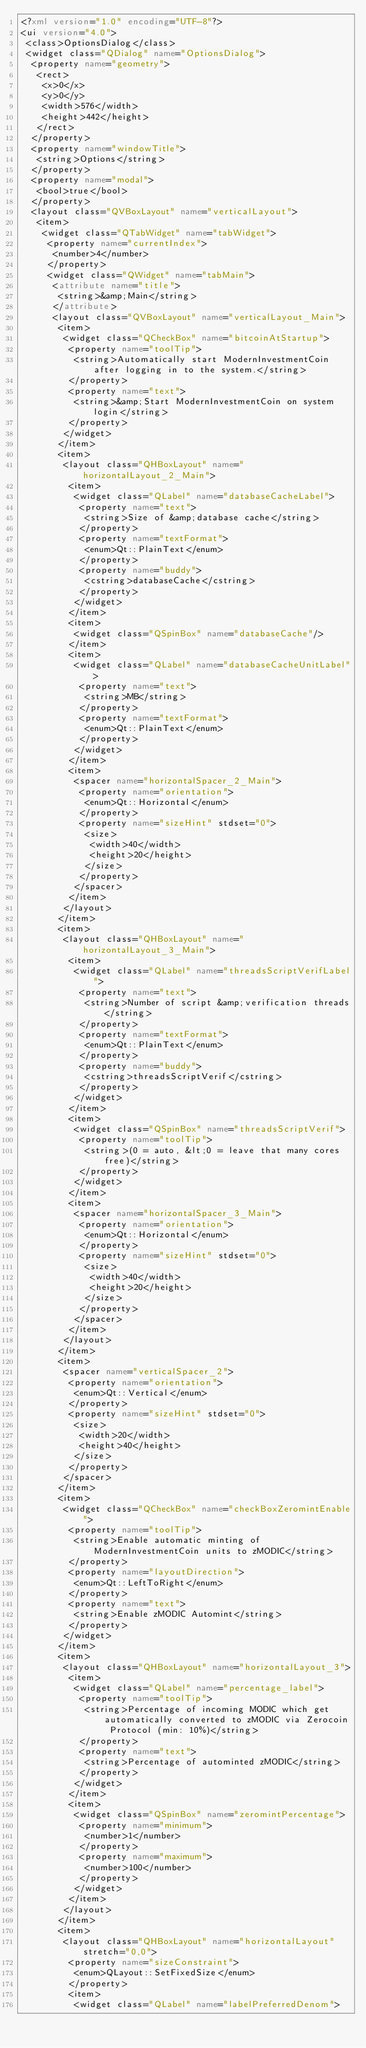Convert code to text. <code><loc_0><loc_0><loc_500><loc_500><_XML_><?xml version="1.0" encoding="UTF-8"?>
<ui version="4.0">
 <class>OptionsDialog</class>
 <widget class="QDialog" name="OptionsDialog">
  <property name="geometry">
   <rect>
    <x>0</x>
    <y>0</y>
    <width>576</width>
    <height>442</height>
   </rect>
  </property>
  <property name="windowTitle">
   <string>Options</string>
  </property>
  <property name="modal">
   <bool>true</bool>
  </property>
  <layout class="QVBoxLayout" name="verticalLayout">
   <item>
    <widget class="QTabWidget" name="tabWidget">
     <property name="currentIndex">
      <number>4</number>
     </property>
     <widget class="QWidget" name="tabMain">
      <attribute name="title">
       <string>&amp;Main</string>
      </attribute>
      <layout class="QVBoxLayout" name="verticalLayout_Main">
       <item>
        <widget class="QCheckBox" name="bitcoinAtStartup">
         <property name="toolTip">
          <string>Automatically start ModernInvestmentCoin after logging in to the system.</string>
         </property>
         <property name="text">
          <string>&amp;Start ModernInvestmentCoin on system login</string>
         </property>
        </widget>
       </item>
       <item>
        <layout class="QHBoxLayout" name="horizontalLayout_2_Main">
         <item>
          <widget class="QLabel" name="databaseCacheLabel">
           <property name="text">
            <string>Size of &amp;database cache</string>
           </property>
           <property name="textFormat">
            <enum>Qt::PlainText</enum>
           </property>
           <property name="buddy">
            <cstring>databaseCache</cstring>
           </property>
          </widget>
         </item>
         <item>
          <widget class="QSpinBox" name="databaseCache"/>
         </item>
         <item>
          <widget class="QLabel" name="databaseCacheUnitLabel">
           <property name="text">
            <string>MB</string>
           </property>
           <property name="textFormat">
            <enum>Qt::PlainText</enum>
           </property>
          </widget>
         </item>
         <item>
          <spacer name="horizontalSpacer_2_Main">
           <property name="orientation">
            <enum>Qt::Horizontal</enum>
           </property>
           <property name="sizeHint" stdset="0">
            <size>
             <width>40</width>
             <height>20</height>
            </size>
           </property>
          </spacer>
         </item>
        </layout>
       </item>
       <item>
        <layout class="QHBoxLayout" name="horizontalLayout_3_Main">
         <item>
          <widget class="QLabel" name="threadsScriptVerifLabel">
           <property name="text">
            <string>Number of script &amp;verification threads</string>
           </property>
           <property name="textFormat">
            <enum>Qt::PlainText</enum>
           </property>
           <property name="buddy">
            <cstring>threadsScriptVerif</cstring>
           </property>
          </widget>
         </item>
         <item>
          <widget class="QSpinBox" name="threadsScriptVerif">
           <property name="toolTip">
            <string>(0 = auto, &lt;0 = leave that many cores free)</string>
           </property>
          </widget>
         </item>
         <item>
          <spacer name="horizontalSpacer_3_Main">
           <property name="orientation">
            <enum>Qt::Horizontal</enum>
           </property>
           <property name="sizeHint" stdset="0">
            <size>
             <width>40</width>
             <height>20</height>
            </size>
           </property>
          </spacer>
         </item>
        </layout>
       </item>
       <item>
        <spacer name="verticalSpacer_2">
         <property name="orientation">
          <enum>Qt::Vertical</enum>
         </property>
         <property name="sizeHint" stdset="0">
          <size>
           <width>20</width>
           <height>40</height>
          </size>
         </property>
        </spacer>
       </item>
       <item>
        <widget class="QCheckBox" name="checkBoxZeromintEnable">
         <property name="toolTip">
          <string>Enable automatic minting of ModernInvestmentCoin units to zMODIC</string>
         </property>
         <property name="layoutDirection">
          <enum>Qt::LeftToRight</enum>
         </property>
         <property name="text">
          <string>Enable zMODIC Automint</string>
         </property>
        </widget>
       </item>
       <item>
        <layout class="QHBoxLayout" name="horizontalLayout_3">
         <item>
          <widget class="QLabel" name="percentage_label">
           <property name="toolTip">
            <string>Percentage of incoming MODIC which get automatically converted to zMODIC via Zerocoin Protocol (min: 10%)</string>
           </property>
           <property name="text">
            <string>Percentage of autominted zMODIC</string>
           </property>
          </widget>
         </item>
         <item>
          <widget class="QSpinBox" name="zeromintPercentage">
           <property name="minimum">
            <number>1</number>
           </property>
           <property name="maximum">
            <number>100</number>
           </property>
          </widget>
         </item>
        </layout>
       </item>
       <item>
        <layout class="QHBoxLayout" name="horizontalLayout" stretch="0,0">
         <property name="sizeConstraint">
          <enum>QLayout::SetFixedSize</enum>
         </property>
         <item>
          <widget class="QLabel" name="labelPreferredDenom"></code> 